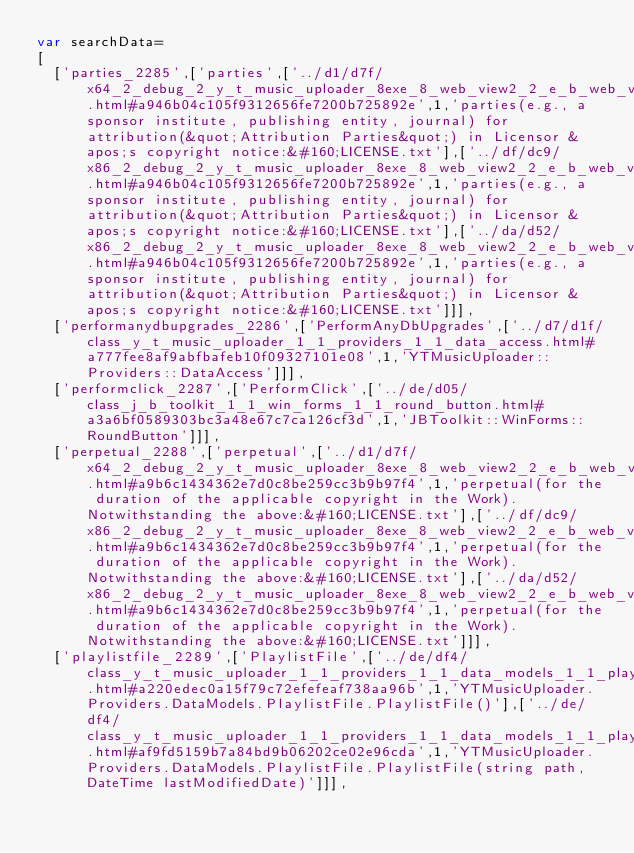<code> <loc_0><loc_0><loc_500><loc_500><_JavaScript_>var searchData=
[
  ['parties_2285',['parties',['../d1/d7f/x64_2_debug_2_y_t_music_uploader_8exe_8_web_view2_2_e_b_web_view_2_subresource_01_filter_2_unind5f0fadb0d26e94109bd811fb51d258a3.html#a946b04c105f9312656fe7200b725892e',1,'parties(e.g., a sponsor institute, publishing entity, journal) for attribution(&quot;Attribution Parties&quot;) in Licensor &apos;s copyright notice:&#160;LICENSE.txt'],['../df/dc9/x86_2_debug_2_y_t_music_uploader_8exe_8_web_view2_2_e_b_web_view_2_subresource_01_filter_2_unind18f0d0a5a6e93d3a508b0b135d70740f.html#a946b04c105f9312656fe7200b725892e',1,'parties(e.g., a sponsor institute, publishing entity, journal) for attribution(&quot;Attribution Parties&quot;) in Licensor &apos;s copyright notice:&#160;LICENSE.txt'],['../da/d52/x86_2_debug_2_y_t_music_uploader_8exe_8_web_view2_2_e_b_web_view_2_subresource_01_filter_2_unind16b5103fa3250163b722a2dafe98da94.html#a946b04c105f9312656fe7200b725892e',1,'parties(e.g., a sponsor institute, publishing entity, journal) for attribution(&quot;Attribution Parties&quot;) in Licensor &apos;s copyright notice:&#160;LICENSE.txt']]],
  ['performanydbupgrades_2286',['PerformAnyDbUpgrades',['../d7/d1f/class_y_t_music_uploader_1_1_providers_1_1_data_access.html#a777fee8af9abfbafeb10f09327101e08',1,'YTMusicUploader::Providers::DataAccess']]],
  ['performclick_2287',['PerformClick',['../de/d05/class_j_b_toolkit_1_1_win_forms_1_1_round_button.html#a3a6bf0589303bc3a48e67c7ca126cf3d',1,'JBToolkit::WinForms::RoundButton']]],
  ['perpetual_2288',['perpetual',['../d1/d7f/x64_2_debug_2_y_t_music_uploader_8exe_8_web_view2_2_e_b_web_view_2_subresource_01_filter_2_unind5f0fadb0d26e94109bd811fb51d258a3.html#a9b6c1434362e7d0c8be259cc3b9b97f4',1,'perpetual(for the duration of the applicable copyright in the Work). Notwithstanding the above:&#160;LICENSE.txt'],['../df/dc9/x86_2_debug_2_y_t_music_uploader_8exe_8_web_view2_2_e_b_web_view_2_subresource_01_filter_2_unind18f0d0a5a6e93d3a508b0b135d70740f.html#a9b6c1434362e7d0c8be259cc3b9b97f4',1,'perpetual(for the duration of the applicable copyright in the Work). Notwithstanding the above:&#160;LICENSE.txt'],['../da/d52/x86_2_debug_2_y_t_music_uploader_8exe_8_web_view2_2_e_b_web_view_2_subresource_01_filter_2_unind16b5103fa3250163b722a2dafe98da94.html#a9b6c1434362e7d0c8be259cc3b9b97f4',1,'perpetual(for the duration of the applicable copyright in the Work). Notwithstanding the above:&#160;LICENSE.txt']]],
  ['playlistfile_2289',['PlaylistFile',['../de/df4/class_y_t_music_uploader_1_1_providers_1_1_data_models_1_1_playlist_file.html#a220edec0a15f79c72efefeaf738aa96b',1,'YTMusicUploader.Providers.DataModels.PlaylistFile.PlaylistFile()'],['../de/df4/class_y_t_music_uploader_1_1_providers_1_1_data_models_1_1_playlist_file.html#af9fd5159b7a84bd9b06202ce02e96cda',1,'YTMusicUploader.Providers.DataModels.PlaylistFile.PlaylistFile(string path, DateTime lastModifiedDate)']]],</code> 